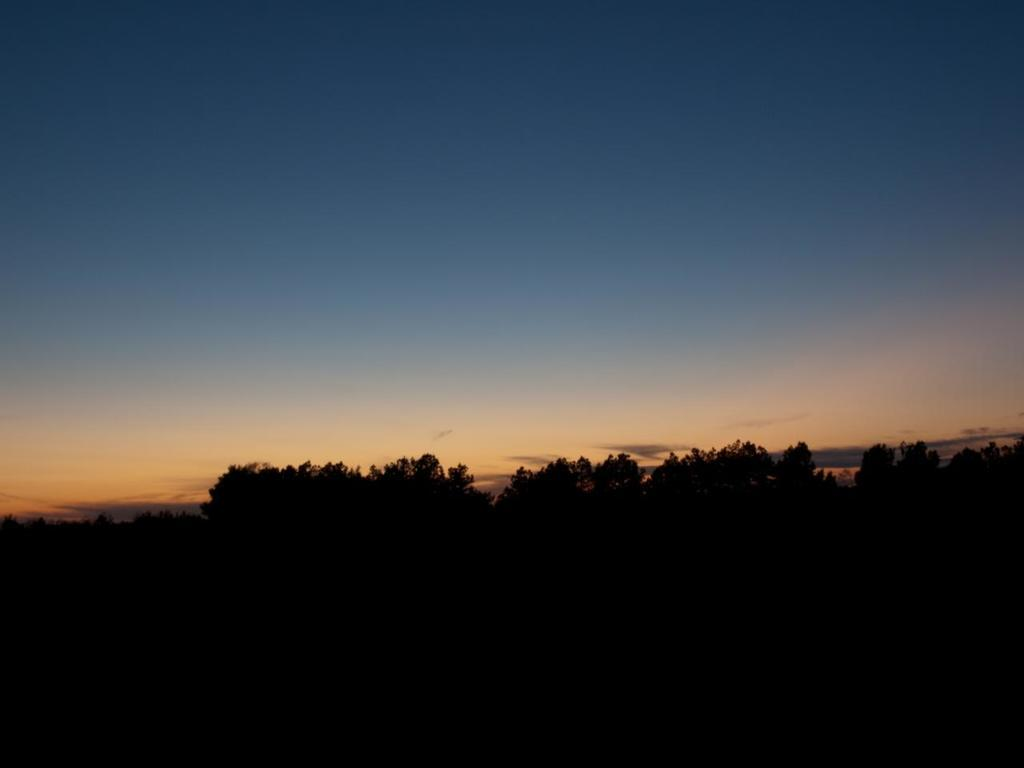What type of vegetation can be seen in the image? There are trees in the image. What part of the natural environment is visible in the image? The sky is visible in the background of the image. How would you describe the lighting in the image? The image appears to be slightly dark. What type of coach is present in the image? There is no coach present in the image; it features trees and a sky background. Whose birthday is being celebrated in the image? There is no indication of a birthday celebration in the image. 